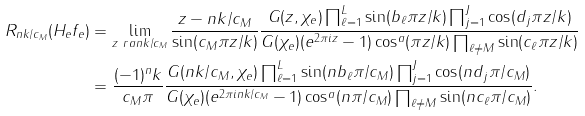Convert formula to latex. <formula><loc_0><loc_0><loc_500><loc_500>R _ { n k / c _ { M } } ( H _ { e } f _ { e } ) & = \lim _ { z \ r a n k / c _ { M } } \frac { z - n k / c _ { M } } { \sin ( c _ { M } \pi z / k ) } \frac { G ( z , \chi _ { e } ) \prod _ { \ell = 1 } ^ { L } \sin ( b _ { \ell } \pi z / k ) \prod _ { j = 1 } ^ { J } \cos ( d _ { j } \pi z / k ) } { G ( \chi _ { e } ) ( e ^ { 2 \pi i z } - 1 ) \cos ^ { a } ( \pi z / k ) \prod _ { \ell \neq M } \sin ( c _ { \ell } \pi z / k ) } \\ & = \frac { ( - 1 ) ^ { n } k } { c _ { M } \pi } \frac { G ( n k / c _ { M } , \chi _ { e } ) \prod _ { \ell = 1 } ^ { L } \sin ( n b _ { \ell } \pi / c _ { M } ) \prod _ { j = 1 } ^ { J } \cos ( n d _ { j } \pi / c _ { M } ) } { G ( \chi _ { e } ) ( e ^ { 2 \pi i n k / c _ { M } } - 1 ) \cos ^ { a } ( n \pi / c _ { M } ) \prod _ { \ell \neq M } \sin ( n c _ { \ell } \pi / c _ { M } ) } .</formula> 